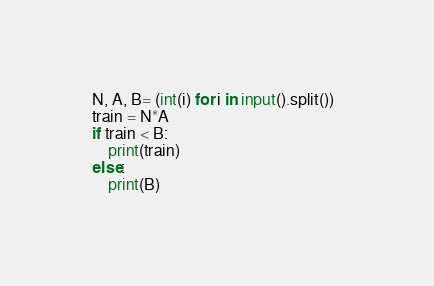Convert code to text. <code><loc_0><loc_0><loc_500><loc_500><_Python_>N, A, B= (int(i) for i in input().split())  
train = N*A
if train < B:
	print(train)
else:
	print(B)</code> 